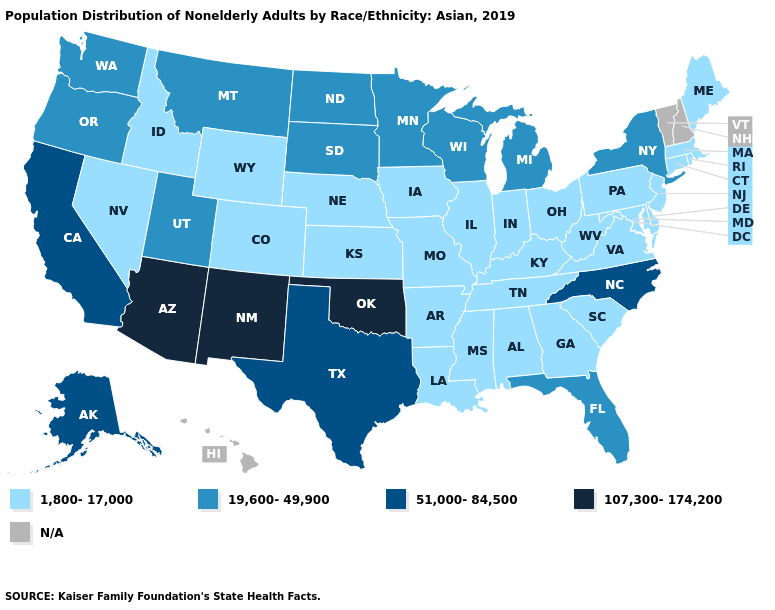What is the value of Indiana?
Quick response, please. 1,800-17,000. Name the states that have a value in the range 19,600-49,900?
Write a very short answer. Florida, Michigan, Minnesota, Montana, New York, North Dakota, Oregon, South Dakota, Utah, Washington, Wisconsin. Name the states that have a value in the range 51,000-84,500?
Write a very short answer. Alaska, California, North Carolina, Texas. What is the value of Texas?
Be succinct. 51,000-84,500. Which states have the lowest value in the USA?
Be succinct. Alabama, Arkansas, Colorado, Connecticut, Delaware, Georgia, Idaho, Illinois, Indiana, Iowa, Kansas, Kentucky, Louisiana, Maine, Maryland, Massachusetts, Mississippi, Missouri, Nebraska, Nevada, New Jersey, Ohio, Pennsylvania, Rhode Island, South Carolina, Tennessee, Virginia, West Virginia, Wyoming. What is the value of Iowa?
Answer briefly. 1,800-17,000. Does New York have the highest value in the Northeast?
Quick response, please. Yes. Does Massachusetts have the lowest value in the Northeast?
Answer briefly. Yes. Among the states that border California , does Nevada have the lowest value?
Write a very short answer. Yes. Among the states that border Florida , which have the highest value?
Quick response, please. Alabama, Georgia. What is the value of Montana?
Give a very brief answer. 19,600-49,900. How many symbols are there in the legend?
Be succinct. 5. What is the highest value in states that border North Dakota?
Keep it brief. 19,600-49,900. Name the states that have a value in the range 51,000-84,500?
Quick response, please. Alaska, California, North Carolina, Texas. What is the value of Louisiana?
Keep it brief. 1,800-17,000. 